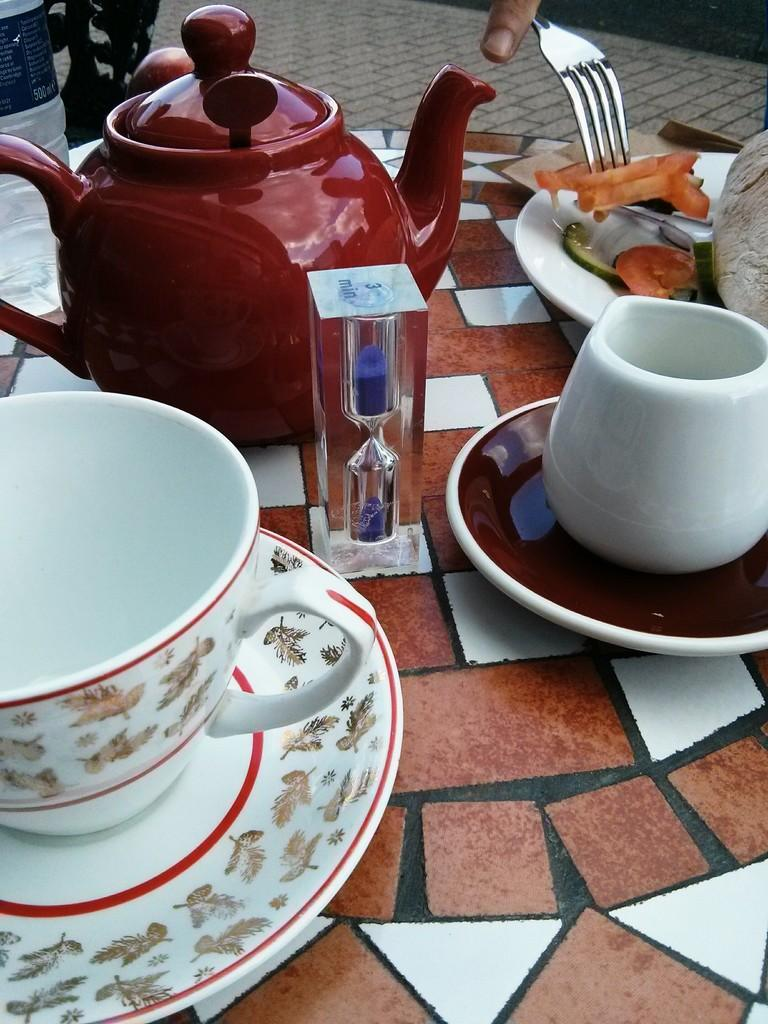What is the main object in the image? There is a kettle in the image. What other objects are visible on the right side of the image? There is a cup and saucer on the right side of the image. What can be seen on the plate in the image? There is a plate of food in the image. What is the person in the image holding? A person is holding a fork in the image. What type of stick is the person using to stir the food in the image? There is no stick visible in the image; the person is holding a fork. 